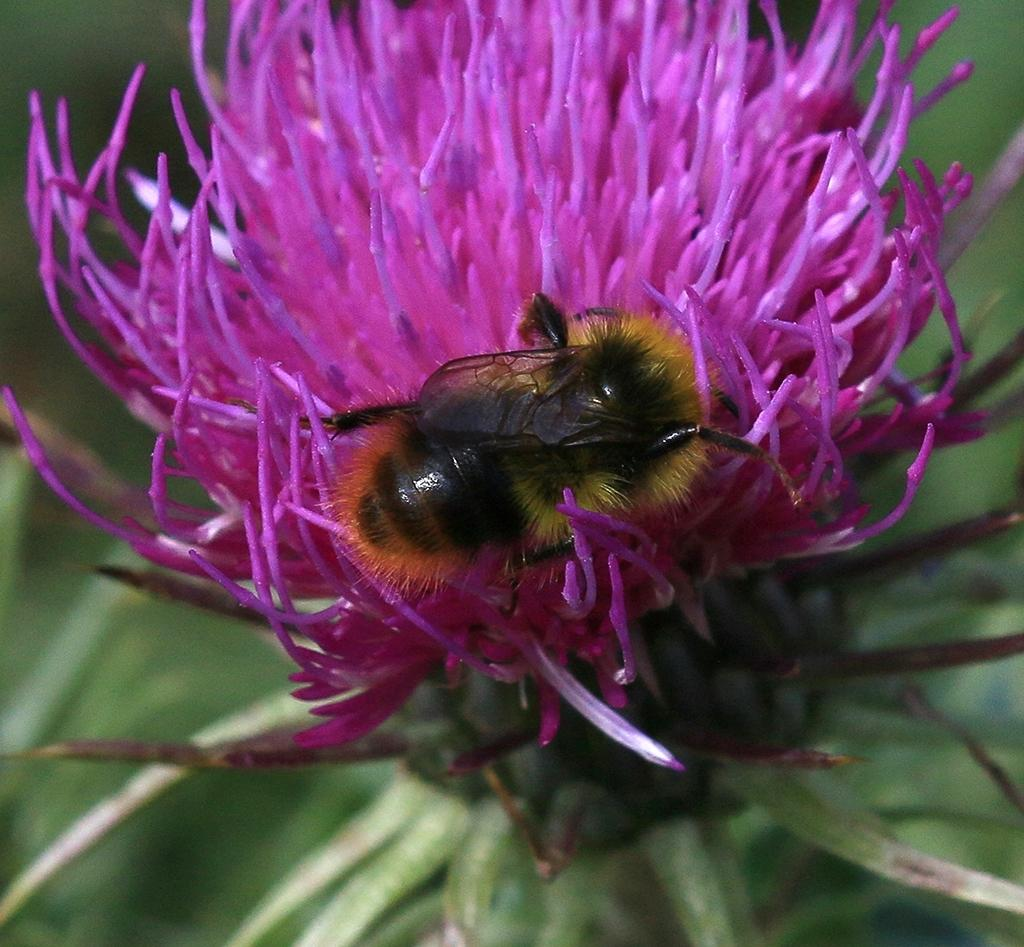What is present in the image? There is a bug in the image. Where is the bug located? The bug is on a flower. What type of brain can be seen in the image? There is no brain present in the image; it features a bug on a flower. Is the bug stuck in quicksand in the image? There is no quicksand present in the image; the bug is on a flower. 